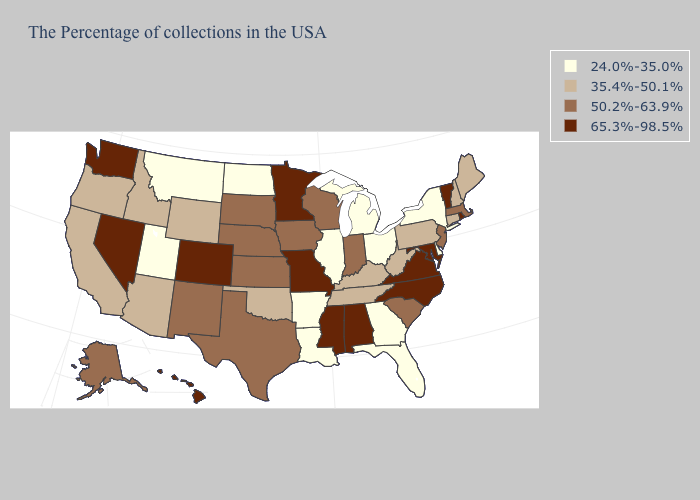Does Colorado have a higher value than Nevada?
Give a very brief answer. No. What is the value of Arkansas?
Quick response, please. 24.0%-35.0%. What is the value of Rhode Island?
Keep it brief. 65.3%-98.5%. Does Idaho have the same value as Florida?
Answer briefly. No. Among the states that border South Carolina , does North Carolina have the lowest value?
Keep it brief. No. Does West Virginia have the same value as Alabama?
Give a very brief answer. No. What is the value of Arizona?
Concise answer only. 35.4%-50.1%. Does Minnesota have the highest value in the MidWest?
Short answer required. Yes. What is the value of Maine?
Answer briefly. 35.4%-50.1%. What is the value of Alabama?
Quick response, please. 65.3%-98.5%. Does Utah have the highest value in the West?
Keep it brief. No. Name the states that have a value in the range 35.4%-50.1%?
Write a very short answer. Maine, New Hampshire, Connecticut, Pennsylvania, West Virginia, Kentucky, Tennessee, Oklahoma, Wyoming, Arizona, Idaho, California, Oregon. Does Maryland have the lowest value in the USA?
Write a very short answer. No. What is the highest value in the USA?
Write a very short answer. 65.3%-98.5%. Is the legend a continuous bar?
Keep it brief. No. 